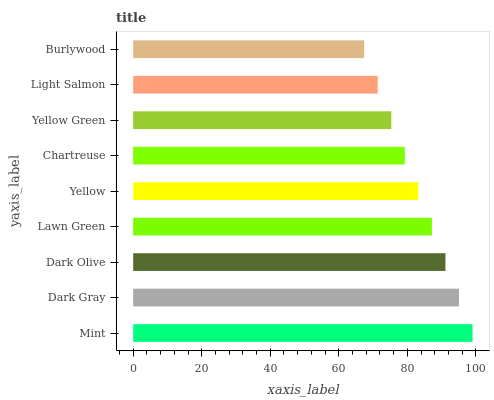Is Burlywood the minimum?
Answer yes or no. Yes. Is Mint the maximum?
Answer yes or no. Yes. Is Dark Gray the minimum?
Answer yes or no. No. Is Dark Gray the maximum?
Answer yes or no. No. Is Mint greater than Dark Gray?
Answer yes or no. Yes. Is Dark Gray less than Mint?
Answer yes or no. Yes. Is Dark Gray greater than Mint?
Answer yes or no. No. Is Mint less than Dark Gray?
Answer yes or no. No. Is Yellow the high median?
Answer yes or no. Yes. Is Yellow the low median?
Answer yes or no. Yes. Is Dark Olive the high median?
Answer yes or no. No. Is Dark Olive the low median?
Answer yes or no. No. 